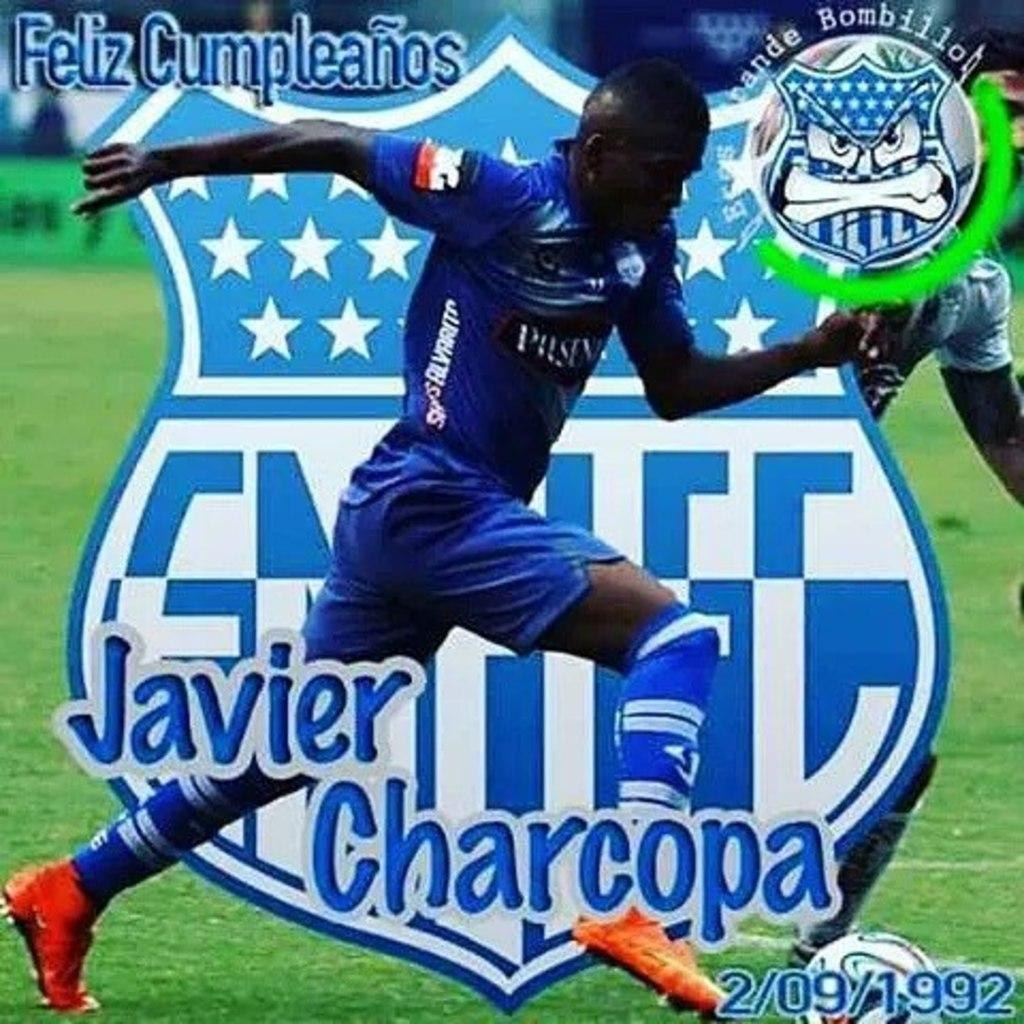<image>
Provide a brief description of the given image. Javier Charcopa is dribbling a soccer ball in front of a crest. 